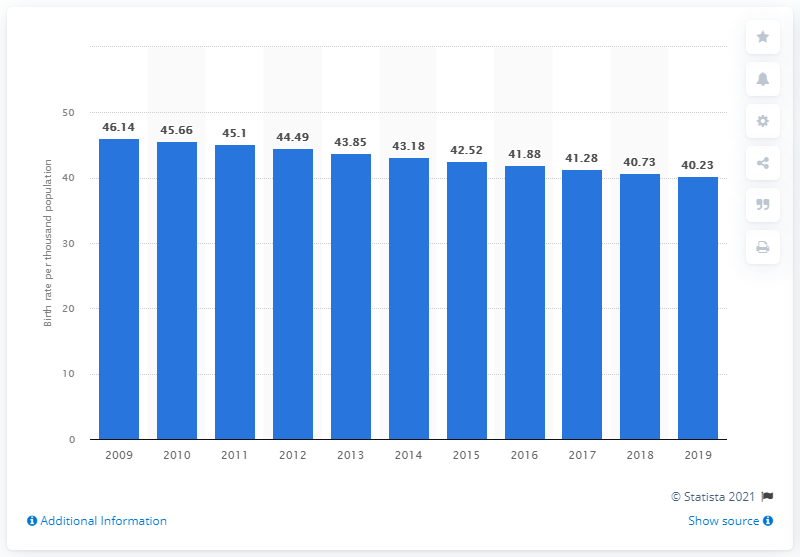Outline some significant characteristics in this image. In 2019, the crude birth rate in Angola was 40.23 births per 1,000 people. 